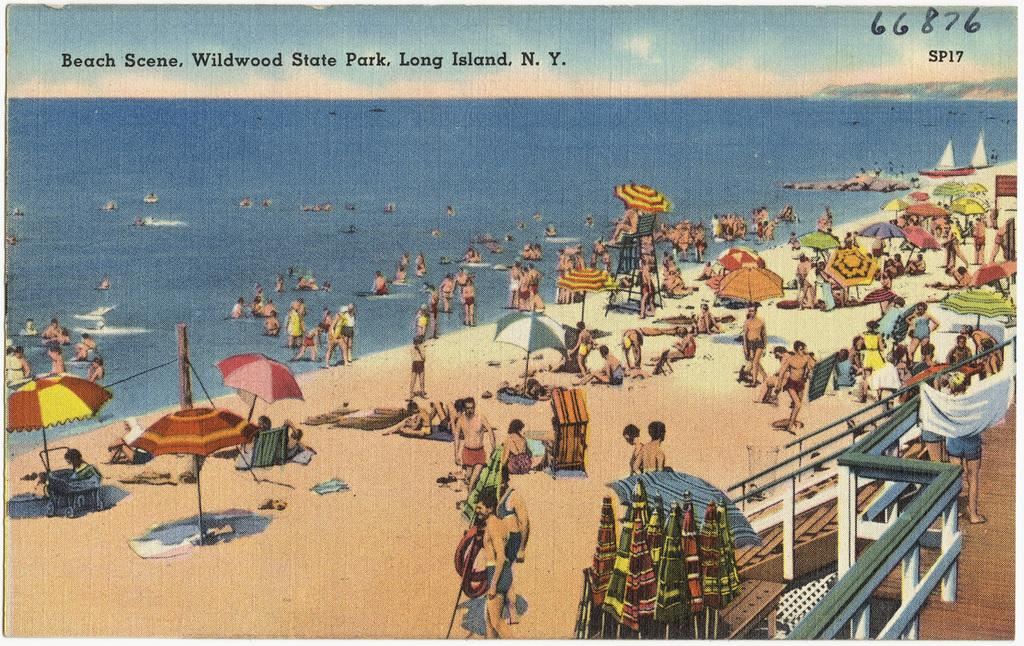<image>
Share a concise interpretation of the image provided. A postcard from Wildwood State Park features people relaxing at the beach. 